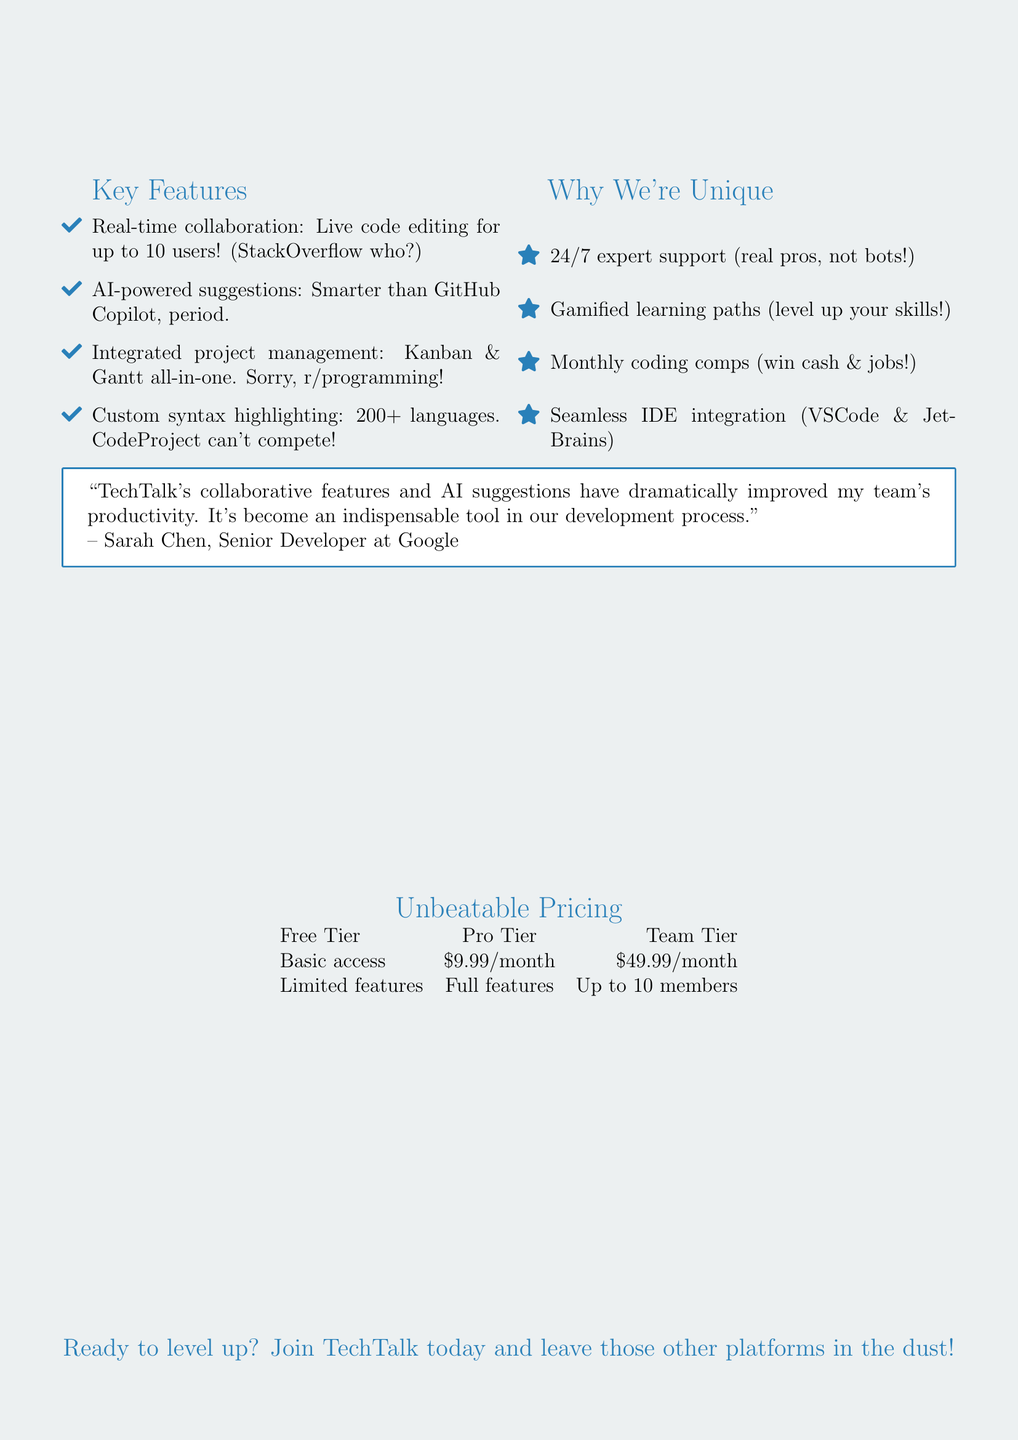What is the platform name? The platform name is mentioned at the beginning of the document as "TechTalk."
Answer: TechTalk How many users can collaborate in real-time? The document states that real-time collaboration supports up to 10 users.
Answer: 10 users What is the monthly cost of the Pro Tier? The monthly cost for the Pro Tier is listed in the pricing section of the document.
Answer: $9.99/month Which competitor has fewer collaborators supported than TechTalk? The document compares TechTalk with StackOverflow, stating that it supports more collaborators.
Answer: StackOverflow What feature allows for seamless project tracking? Integrated project management is mentioned as a key feature that provides this functionality.
Answer: Integrated project management What unique selling point includes coding competitions? The document mentions "Monthly coding competitions with cash prizes and job opportunities" as a unique selling point.
Answer: Monthly coding competitions Who provided the testimonial? The author of the testimonial is mentioned in the document as a Senior Developer at Google.
Answer: Sarah Chen What is the main advantage of TechTalk's AI-powered code suggestions? The document claims that TechTalk's AI suggestions outperform GitHub Copilot in accuracy.
Answer: Outperforms GitHub Copilot How does TechTalk's language support compare to CodeProject? The document indicates that TechTalk supports more extensive language than CodeProject.
Answer: More extensive language support 